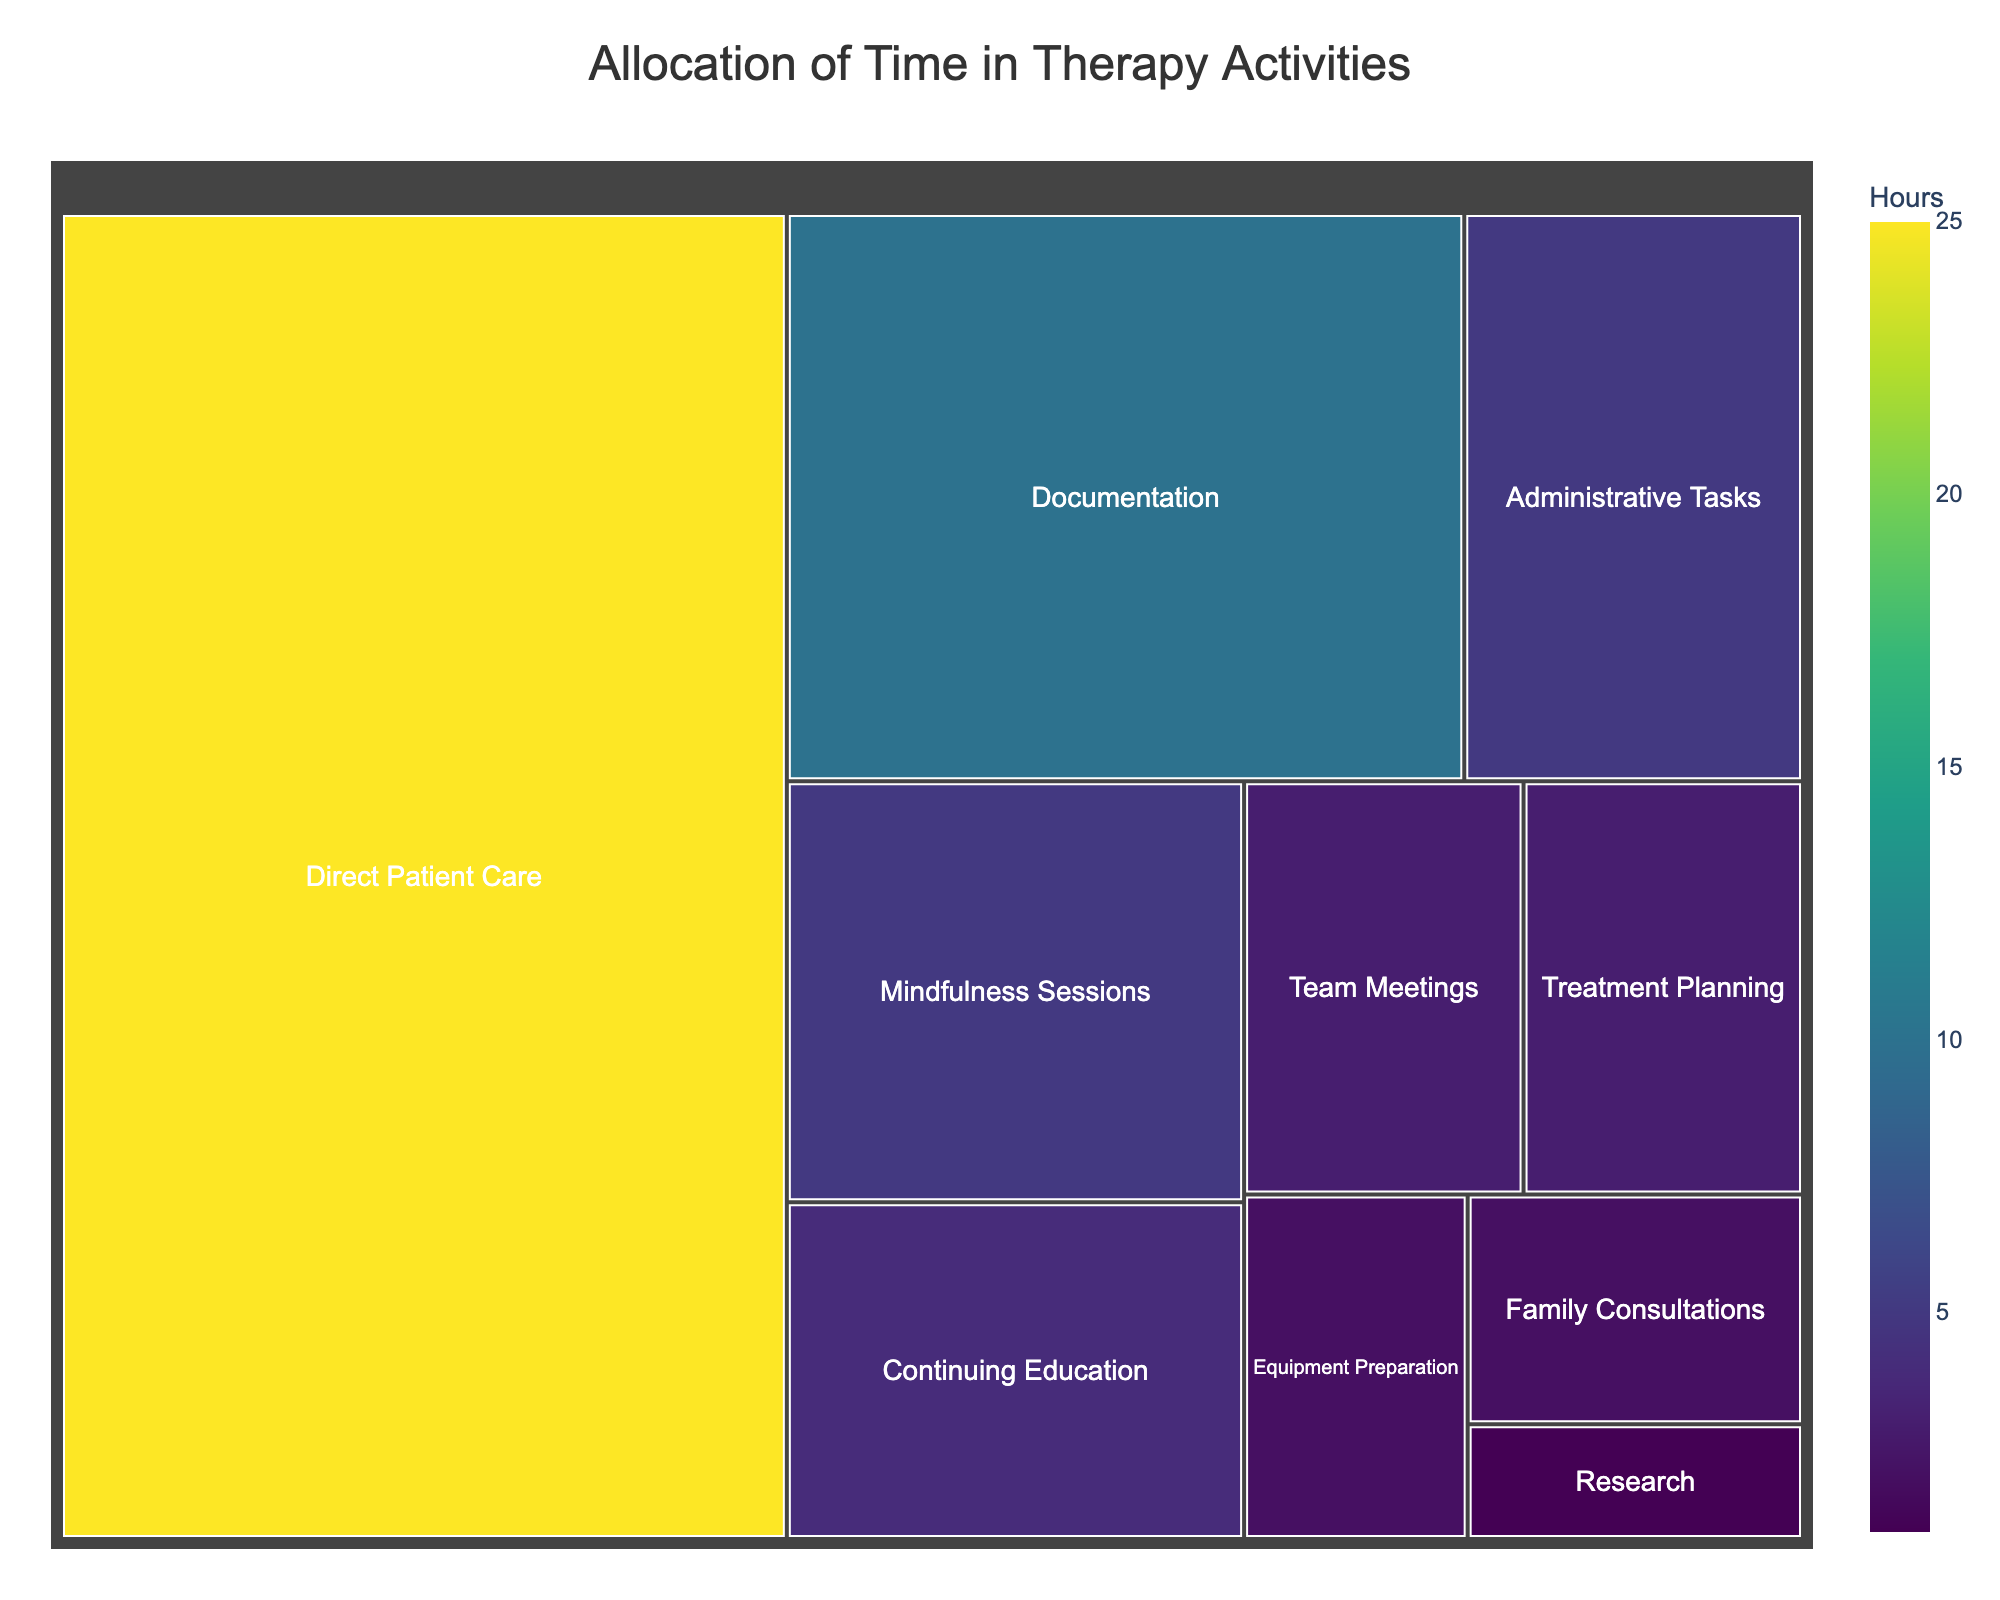How many hours are allocated to Direct Patient Care? To find this, locate the section labeled "Direct Patient Care" on the treemap, which shows 25 hours.
Answer: 25 How much more time is spent on Documentation compared to Continuing Education? Subtract the hours allocated to Continuing Education from the hours allocated to Documentation. Documentation is 10 hours and Continuing Education is 4 hours, so 10 - 4 = 6 hours.
Answer: 6 Which activity has the smallest allocation of time? Locate the activity with the smallest value in hours on the treemap, which is Research with 1 hour.
Answer: Research What is the total time spent on Mindfulness Sessions and Family Consultations combined? Add the hours for Mindfulness Sessions and Family Consultations. Mindfulness Sessions have 5 hours and Family Consultations have 2 hours, so 5 + 2 = 7 hours.
Answer: 7 Is more time spent on Administrative Tasks or Treatment Planning? Compare the hours for Administrative Tasks and Treatment Planning on the treemap. Administrative Tasks have 5 hours, while Treatment Planning has 3 hours.
Answer: Administrative Tasks What is the largest category of time allocation? Identify the section with the largest value on the treemap, which is Direct Patient Care with 25 hours.
Answer: Direct Patient Care Among Team Meetings, Equipment Preparation, and Research, which activity takes the longest time? Compare the hours for Team Meetings, Equipment Preparation, and Research. Team Meetings have 3 hours, Equipment Preparation has 2 hours, and Research has 1 hour.
Answer: Team Meetings What is the total time allocated for activities excluding Direct Patient Care and Documentation? Sum the hours of all activities and then subtract the hours for Direct Patient Care and Documentation. Total hours = 25 + 10 + 5 + 4 + 3 + 3 + 2 + 2 + 1 + 5 = 60. Excluding Direct Patient Care and Documentation, the sum is 60 - 25 - 10 = 25 hours.
Answer: 25 Which activity uses the same amount of time as Administrative Tasks? Identify the activity with the same allocated hours as Administrative Tasks on the treemap. Both Administrative Tasks and Mindfulness Sessions are allocated 5 hours.
Answer: Mindfulness Sessions What is the average time spent on each activity? Divide the total time allocated by the number of activities. The total time is 25 + 10 + 5 + 4 + 3 + 3 + 2 + 2 + 1 + 5 = 60 hours, and there are 10 activities. The average is 60 / 10 = 6 hours.
Answer: 6 